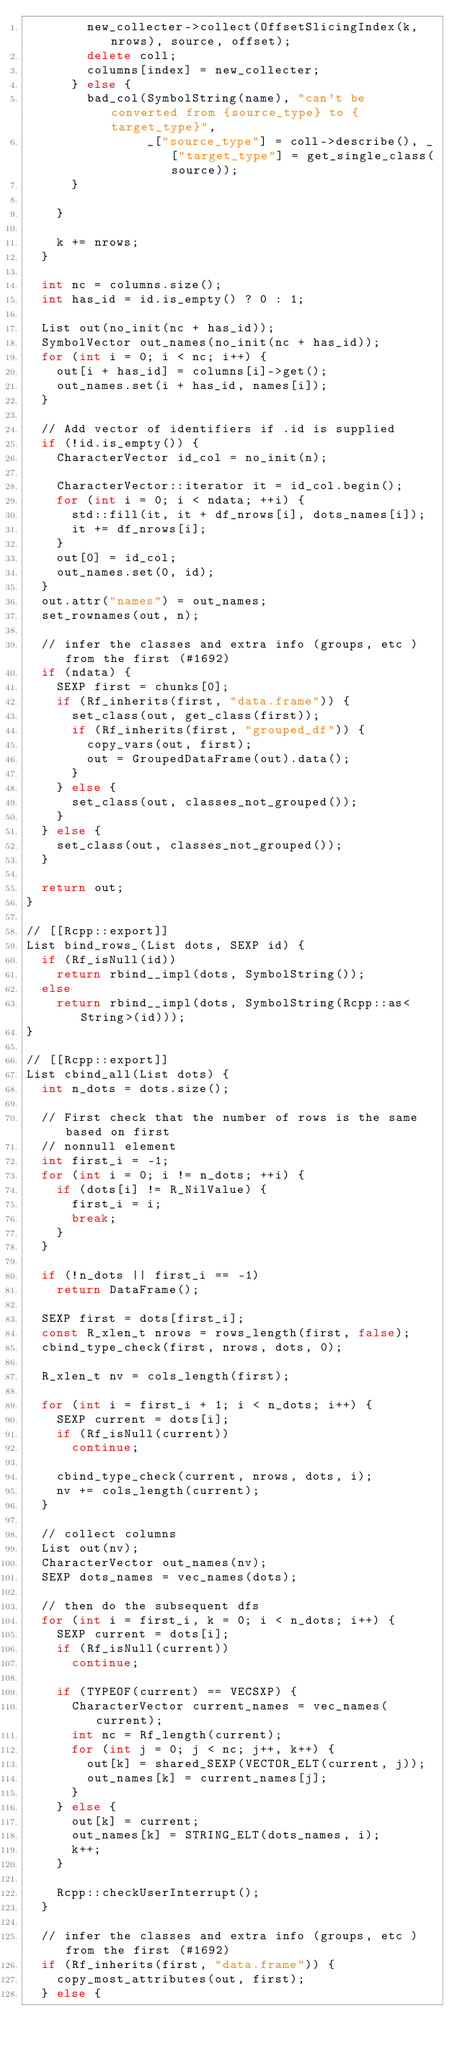Convert code to text. <code><loc_0><loc_0><loc_500><loc_500><_C++_>        new_collecter->collect(OffsetSlicingIndex(k, nrows), source, offset);
        delete coll;
        columns[index] = new_collecter;
      } else {
        bad_col(SymbolString(name), "can't be converted from {source_type} to {target_type}",
                _["source_type"] = coll->describe(), _["target_type"] = get_single_class(source));
      }

    }

    k += nrows;
  }

  int nc = columns.size();
  int has_id = id.is_empty() ? 0 : 1;

  List out(no_init(nc + has_id));
  SymbolVector out_names(no_init(nc + has_id));
  for (int i = 0; i < nc; i++) {
    out[i + has_id] = columns[i]->get();
    out_names.set(i + has_id, names[i]);
  }

  // Add vector of identifiers if .id is supplied
  if (!id.is_empty()) {
    CharacterVector id_col = no_init(n);

    CharacterVector::iterator it = id_col.begin();
    for (int i = 0; i < ndata; ++i) {
      std::fill(it, it + df_nrows[i], dots_names[i]);
      it += df_nrows[i];
    }
    out[0] = id_col;
    out_names.set(0, id);
  }
  out.attr("names") = out_names;
  set_rownames(out, n);

  // infer the classes and extra info (groups, etc ) from the first (#1692)
  if (ndata) {
    SEXP first = chunks[0];
    if (Rf_inherits(first, "data.frame")) {
      set_class(out, get_class(first));
      if (Rf_inherits(first, "grouped_df")) {
        copy_vars(out, first);
        out = GroupedDataFrame(out).data();
      }
    } else {
      set_class(out, classes_not_grouped());
    }
  } else {
    set_class(out, classes_not_grouped());
  }

  return out;
}

// [[Rcpp::export]]
List bind_rows_(List dots, SEXP id) {
  if (Rf_isNull(id))
    return rbind__impl(dots, SymbolString());
  else
    return rbind__impl(dots, SymbolString(Rcpp::as<String>(id)));
}

// [[Rcpp::export]]
List cbind_all(List dots) {
  int n_dots = dots.size();

  // First check that the number of rows is the same based on first
  // nonnull element
  int first_i = -1;
  for (int i = 0; i != n_dots; ++i) {
    if (dots[i] != R_NilValue) {
      first_i = i;
      break;
    }
  }

  if (!n_dots || first_i == -1)
    return DataFrame();

  SEXP first = dots[first_i];
  const R_xlen_t nrows = rows_length(first, false);
  cbind_type_check(first, nrows, dots, 0);

  R_xlen_t nv = cols_length(first);

  for (int i = first_i + 1; i < n_dots; i++) {
    SEXP current = dots[i];
    if (Rf_isNull(current))
      continue;

    cbind_type_check(current, nrows, dots, i);
    nv += cols_length(current);
  }

  // collect columns
  List out(nv);
  CharacterVector out_names(nv);
  SEXP dots_names = vec_names(dots);

  // then do the subsequent dfs
  for (int i = first_i, k = 0; i < n_dots; i++) {
    SEXP current = dots[i];
    if (Rf_isNull(current))
      continue;

    if (TYPEOF(current) == VECSXP) {
      CharacterVector current_names = vec_names(current);
      int nc = Rf_length(current);
      for (int j = 0; j < nc; j++, k++) {
        out[k] = shared_SEXP(VECTOR_ELT(current, j));
        out_names[k] = current_names[j];
      }
    } else {
      out[k] = current;
      out_names[k] = STRING_ELT(dots_names, i);
      k++;
    }

    Rcpp::checkUserInterrupt();
  }

  // infer the classes and extra info (groups, etc ) from the first (#1692)
  if (Rf_inherits(first, "data.frame")) {
    copy_most_attributes(out, first);
  } else {</code> 